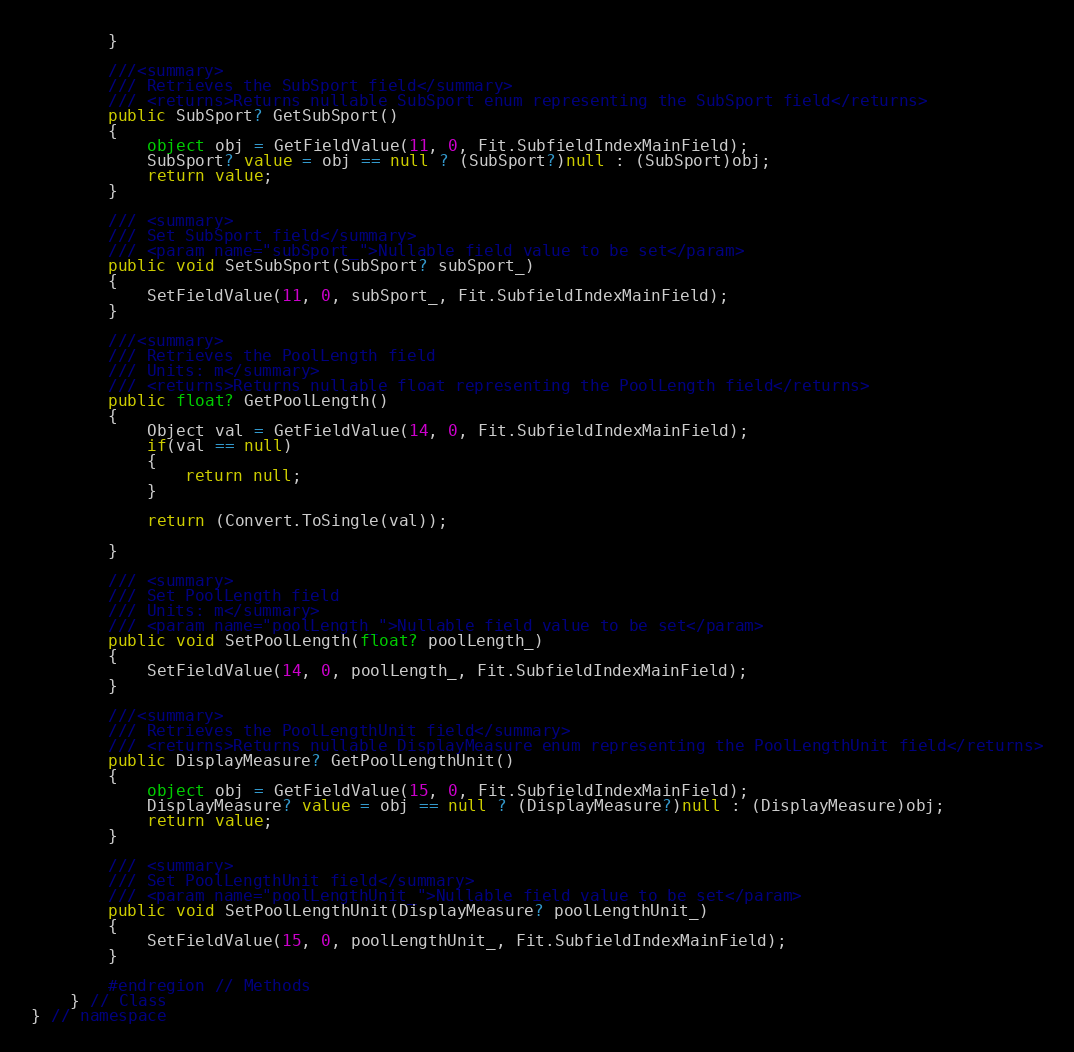Convert code to text. <code><loc_0><loc_0><loc_500><loc_500><_C#_>        }
        
        ///<summary>
        /// Retrieves the SubSport field</summary>
        /// <returns>Returns nullable SubSport enum representing the SubSport field</returns>
        public SubSport? GetSubSport()
        {
            object obj = GetFieldValue(11, 0, Fit.SubfieldIndexMainField);
            SubSport? value = obj == null ? (SubSport?)null : (SubSport)obj;
            return value;
        }

        /// <summary>
        /// Set SubSport field</summary>
        /// <param name="subSport_">Nullable field value to be set</param>
        public void SetSubSport(SubSport? subSport_)
        {
            SetFieldValue(11, 0, subSport_, Fit.SubfieldIndexMainField);
        }
        
        ///<summary>
        /// Retrieves the PoolLength field
        /// Units: m</summary>
        /// <returns>Returns nullable float representing the PoolLength field</returns>
        public float? GetPoolLength()
        {
            Object val = GetFieldValue(14, 0, Fit.SubfieldIndexMainField);
            if(val == null)
            {
                return null;
            }

            return (Convert.ToSingle(val));
            
        }

        /// <summary>
        /// Set PoolLength field
        /// Units: m</summary>
        /// <param name="poolLength_">Nullable field value to be set</param>
        public void SetPoolLength(float? poolLength_)
        {
            SetFieldValue(14, 0, poolLength_, Fit.SubfieldIndexMainField);
        }
        
        ///<summary>
        /// Retrieves the PoolLengthUnit field</summary>
        /// <returns>Returns nullable DisplayMeasure enum representing the PoolLengthUnit field</returns>
        public DisplayMeasure? GetPoolLengthUnit()
        {
            object obj = GetFieldValue(15, 0, Fit.SubfieldIndexMainField);
            DisplayMeasure? value = obj == null ? (DisplayMeasure?)null : (DisplayMeasure)obj;
            return value;
        }

        /// <summary>
        /// Set PoolLengthUnit field</summary>
        /// <param name="poolLengthUnit_">Nullable field value to be set</param>
        public void SetPoolLengthUnit(DisplayMeasure? poolLengthUnit_)
        {
            SetFieldValue(15, 0, poolLengthUnit_, Fit.SubfieldIndexMainField);
        }
        
        #endregion // Methods
    } // Class
} // namespace
</code> 